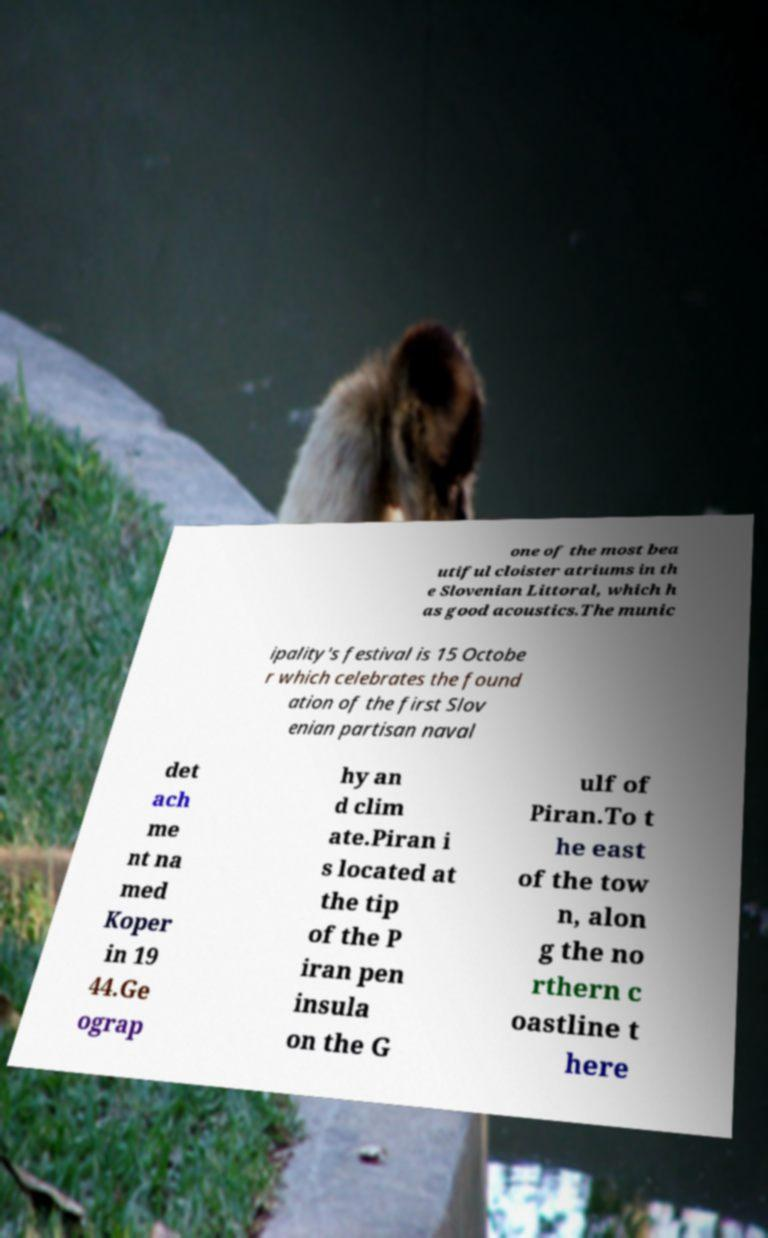Can you accurately transcribe the text from the provided image for me? one of the most bea utiful cloister atriums in th e Slovenian Littoral, which h as good acoustics.The munic ipality's festival is 15 Octobe r which celebrates the found ation of the first Slov enian partisan naval det ach me nt na med Koper in 19 44.Ge ograp hy an d clim ate.Piran i s located at the tip of the P iran pen insula on the G ulf of Piran.To t he east of the tow n, alon g the no rthern c oastline t here 